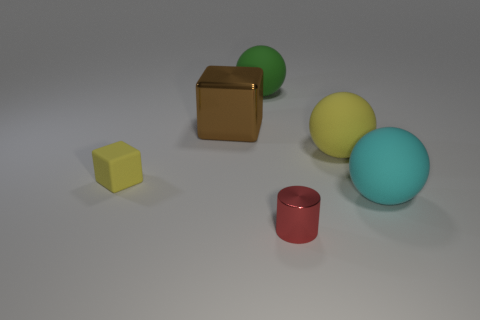Are there any small blocks in front of the big yellow rubber object?
Keep it short and to the point. Yes. How many big yellow objects have the same material as the large brown block?
Offer a terse response. 0. How many things are green matte spheres or big blocks?
Ensure brevity in your answer.  2. Is there a big cyan ball?
Make the answer very short. Yes. What material is the sphere that is on the left side of the metallic thing that is in front of the large thing in front of the small yellow object?
Offer a very short reply. Rubber. Is the number of big green matte things that are behind the brown block less than the number of tiny yellow things?
Offer a terse response. No. What material is the red cylinder that is the same size as the yellow cube?
Your response must be concise. Metal. How big is the matte object that is both in front of the large yellow rubber ball and on the right side of the brown object?
Give a very brief answer. Large. There is another thing that is the same shape as the small yellow rubber thing; what is its size?
Make the answer very short. Large. What number of objects are brown metal cubes or big spheres to the left of the large cyan matte thing?
Your answer should be compact. 3. 